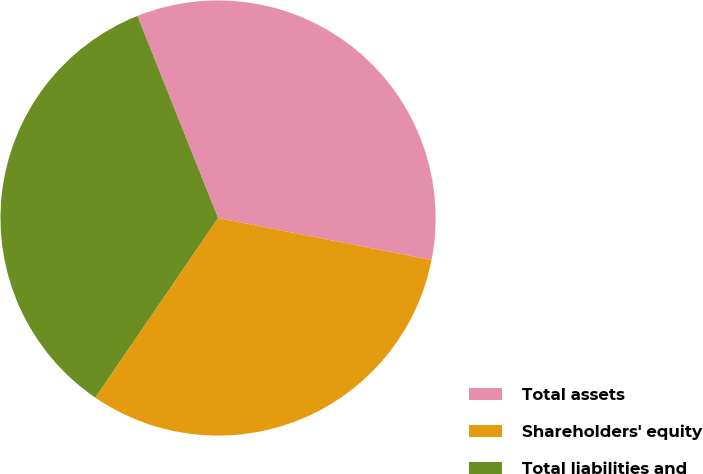<chart> <loc_0><loc_0><loc_500><loc_500><pie_chart><fcel>Total assets<fcel>Shareholders' equity<fcel>Total liabilities and<nl><fcel>34.14%<fcel>31.45%<fcel>34.41%<nl></chart> 